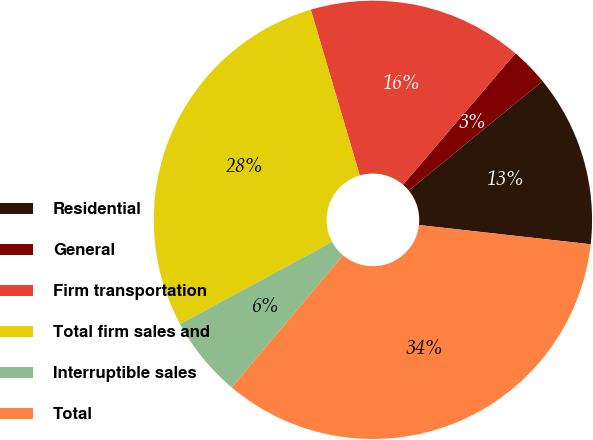<chart> <loc_0><loc_0><loc_500><loc_500><pie_chart><fcel>Residential<fcel>General<fcel>Firm transportation<fcel>Total firm sales and<fcel>Interruptible sales<fcel>Total<nl><fcel>12.69%<fcel>2.82%<fcel>15.84%<fcel>28.31%<fcel>5.97%<fcel>34.37%<nl></chart> 